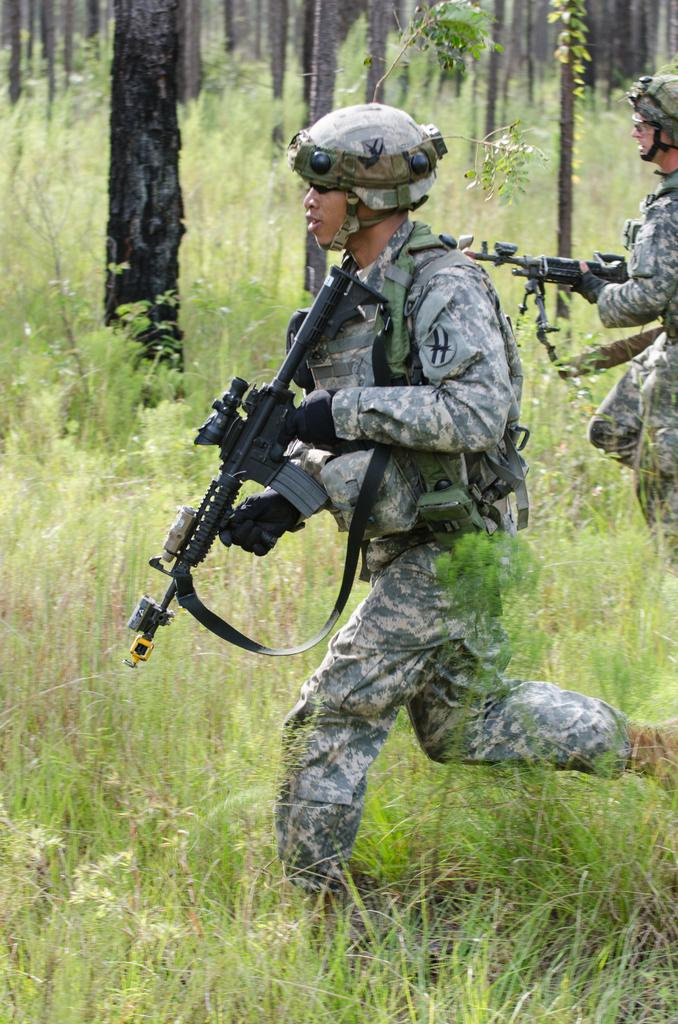How many people are in the image? There are two men in the image. What are the men wearing? The men are wearing army uniforms. What are the men holding in their hands? The men are holding guns in their hands. What type of terrain is visible in the image? There is grass visible on the land. What can be seen in the background of the image? There are trees in the background of the image. Can you tell me how many knives are visible in the image? There are no knives present in the image. What is the name of the son of one of the men in the image? There is no information about the men's sons in the image. 